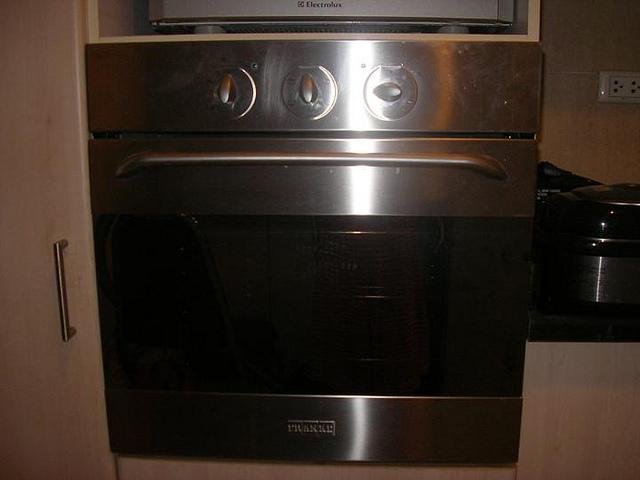Is this oven workable?
Write a very short answer. Yes. What kind of oven is this?
Give a very brief answer. Electric. What color is the oven?
Short answer required. Silver. 